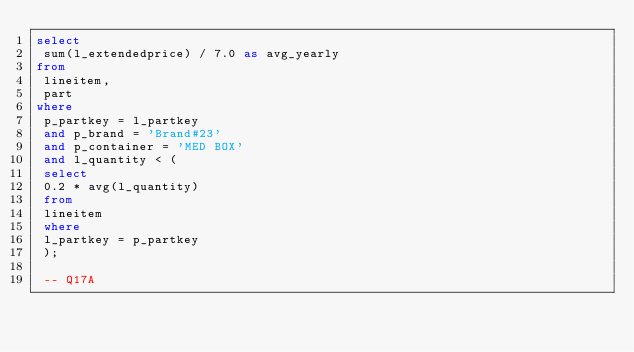<code> <loc_0><loc_0><loc_500><loc_500><_SQL_>select
 sum(l_extendedprice) / 7.0 as avg_yearly
from
 lineitem,
 part
where
 p_partkey = l_partkey
 and p_brand = 'Brand#23'
 and p_container = 'MED BOX'
 and l_quantity < (
 select
 0.2 * avg(l_quantity)
 from
 lineitem
 where
 l_partkey = p_partkey
 );

 -- Q17A</code> 